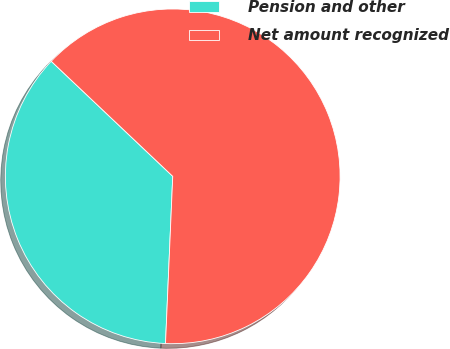Convert chart to OTSL. <chart><loc_0><loc_0><loc_500><loc_500><pie_chart><fcel>Pension and other<fcel>Net amount recognized<nl><fcel>36.38%<fcel>63.62%<nl></chart> 